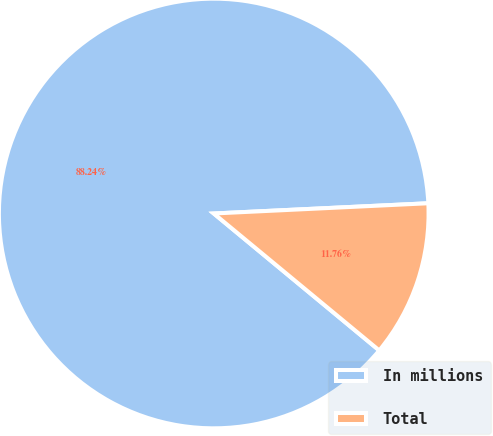Convert chart. <chart><loc_0><loc_0><loc_500><loc_500><pie_chart><fcel>In millions<fcel>Total<nl><fcel>88.24%<fcel>11.76%<nl></chart> 